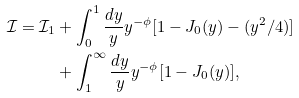<formula> <loc_0><loc_0><loc_500><loc_500>\mathcal { I } = \mathcal { I } _ { 1 } & + \int _ { 0 } ^ { 1 } \frac { d y } { y } y ^ { - \phi } [ 1 - J _ { 0 } ( y ) - ( y ^ { 2 } / 4 ) ] \\ & + \int _ { 1 } ^ { \infty } \frac { d y } { y } y ^ { - \phi } [ 1 - J _ { 0 } ( y ) ] ,</formula> 